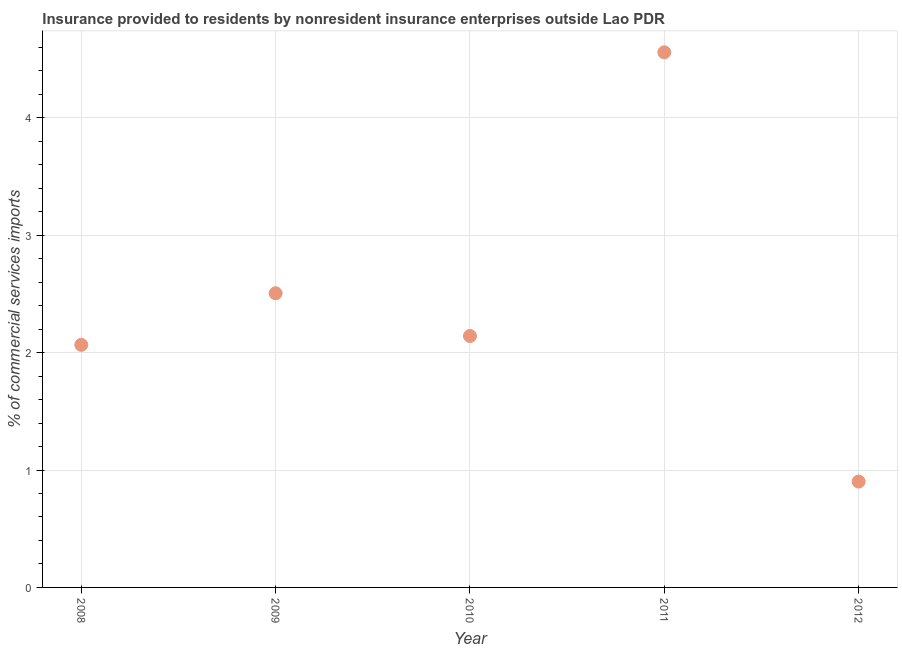What is the insurance provided by non-residents in 2008?
Offer a terse response. 2.07. Across all years, what is the maximum insurance provided by non-residents?
Offer a terse response. 4.56. Across all years, what is the minimum insurance provided by non-residents?
Your answer should be very brief. 0.9. In which year was the insurance provided by non-residents maximum?
Ensure brevity in your answer.  2011. In which year was the insurance provided by non-residents minimum?
Give a very brief answer. 2012. What is the sum of the insurance provided by non-residents?
Your answer should be very brief. 12.17. What is the difference between the insurance provided by non-residents in 2010 and 2011?
Provide a succinct answer. -2.42. What is the average insurance provided by non-residents per year?
Make the answer very short. 2.43. What is the median insurance provided by non-residents?
Give a very brief answer. 2.14. In how many years, is the insurance provided by non-residents greater than 2.4 %?
Your answer should be very brief. 2. Do a majority of the years between 2011 and 2012 (inclusive) have insurance provided by non-residents greater than 1.2 %?
Ensure brevity in your answer.  No. What is the ratio of the insurance provided by non-residents in 2008 to that in 2010?
Provide a short and direct response. 0.96. Is the insurance provided by non-residents in 2008 less than that in 2012?
Your answer should be very brief. No. Is the difference between the insurance provided by non-residents in 2009 and 2012 greater than the difference between any two years?
Offer a very short reply. No. What is the difference between the highest and the second highest insurance provided by non-residents?
Your answer should be compact. 2.05. Is the sum of the insurance provided by non-residents in 2010 and 2012 greater than the maximum insurance provided by non-residents across all years?
Your answer should be compact. No. What is the difference between the highest and the lowest insurance provided by non-residents?
Your response must be concise. 3.66. Does the insurance provided by non-residents monotonically increase over the years?
Your response must be concise. No. How many years are there in the graph?
Offer a very short reply. 5. Does the graph contain any zero values?
Give a very brief answer. No. Does the graph contain grids?
Provide a short and direct response. Yes. What is the title of the graph?
Your response must be concise. Insurance provided to residents by nonresident insurance enterprises outside Lao PDR. What is the label or title of the X-axis?
Provide a succinct answer. Year. What is the label or title of the Y-axis?
Provide a short and direct response. % of commercial services imports. What is the % of commercial services imports in 2008?
Offer a very short reply. 2.07. What is the % of commercial services imports in 2009?
Make the answer very short. 2.51. What is the % of commercial services imports in 2010?
Your answer should be very brief. 2.14. What is the % of commercial services imports in 2011?
Give a very brief answer. 4.56. What is the % of commercial services imports in 2012?
Keep it short and to the point. 0.9. What is the difference between the % of commercial services imports in 2008 and 2009?
Offer a very short reply. -0.44. What is the difference between the % of commercial services imports in 2008 and 2010?
Make the answer very short. -0.08. What is the difference between the % of commercial services imports in 2008 and 2011?
Your response must be concise. -2.49. What is the difference between the % of commercial services imports in 2008 and 2012?
Make the answer very short. 1.16. What is the difference between the % of commercial services imports in 2009 and 2010?
Offer a very short reply. 0.36. What is the difference between the % of commercial services imports in 2009 and 2011?
Your answer should be very brief. -2.05. What is the difference between the % of commercial services imports in 2009 and 2012?
Ensure brevity in your answer.  1.6. What is the difference between the % of commercial services imports in 2010 and 2011?
Make the answer very short. -2.42. What is the difference between the % of commercial services imports in 2010 and 2012?
Your answer should be very brief. 1.24. What is the difference between the % of commercial services imports in 2011 and 2012?
Make the answer very short. 3.66. What is the ratio of the % of commercial services imports in 2008 to that in 2009?
Offer a very short reply. 0.82. What is the ratio of the % of commercial services imports in 2008 to that in 2011?
Provide a short and direct response. 0.45. What is the ratio of the % of commercial services imports in 2008 to that in 2012?
Your answer should be compact. 2.29. What is the ratio of the % of commercial services imports in 2009 to that in 2010?
Offer a terse response. 1.17. What is the ratio of the % of commercial services imports in 2009 to that in 2011?
Provide a short and direct response. 0.55. What is the ratio of the % of commercial services imports in 2009 to that in 2012?
Offer a terse response. 2.78. What is the ratio of the % of commercial services imports in 2010 to that in 2011?
Make the answer very short. 0.47. What is the ratio of the % of commercial services imports in 2010 to that in 2012?
Your answer should be compact. 2.38. What is the ratio of the % of commercial services imports in 2011 to that in 2012?
Your answer should be very brief. 5.05. 